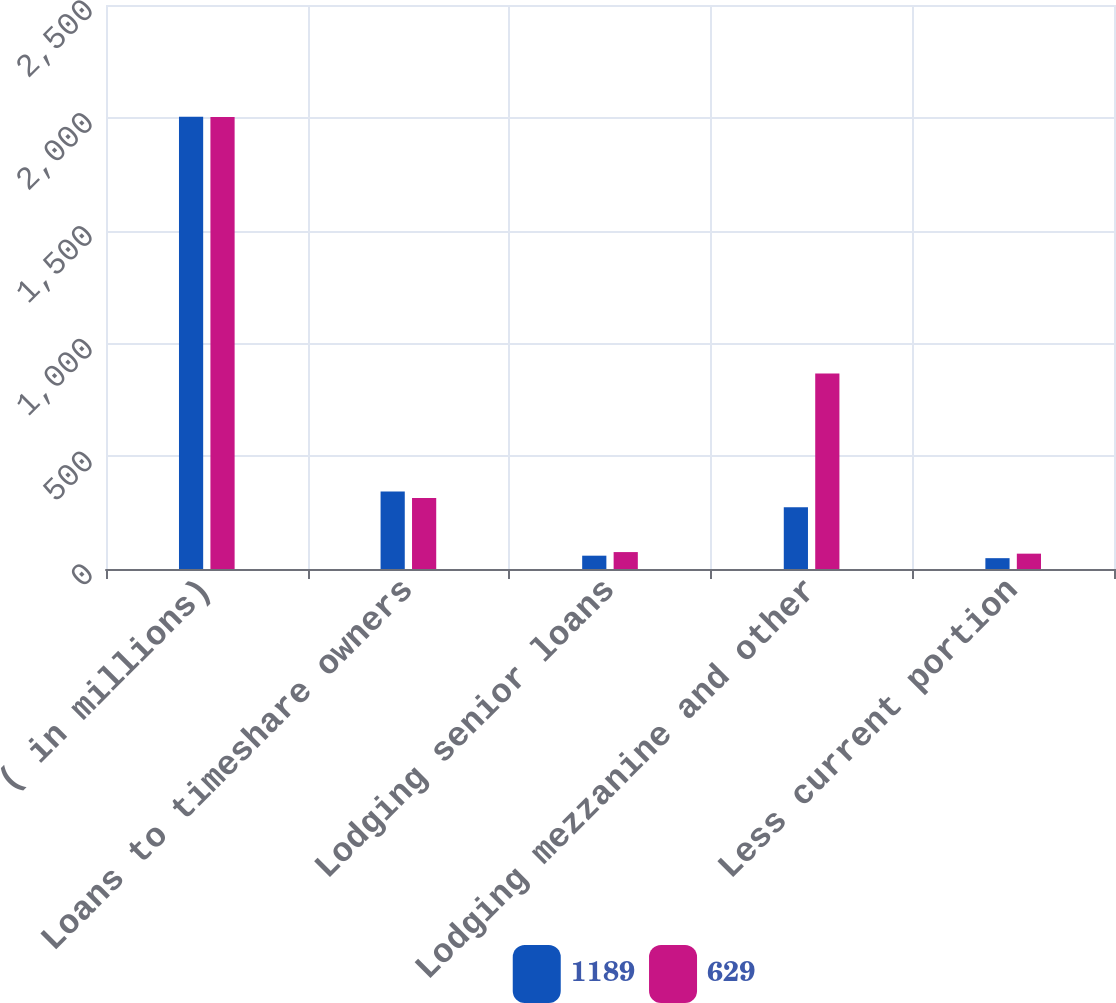Convert chart to OTSL. <chart><loc_0><loc_0><loc_500><loc_500><stacked_bar_chart><ecel><fcel>( in millions)<fcel>Loans to timeshare owners<fcel>Lodging senior loans<fcel>Lodging mezzanine and other<fcel>Less current portion<nl><fcel>1189<fcel>2005<fcel>344<fcel>59<fcel>274<fcel>48<nl><fcel>629<fcel>2004<fcel>315<fcel>75<fcel>867<fcel>68<nl></chart> 